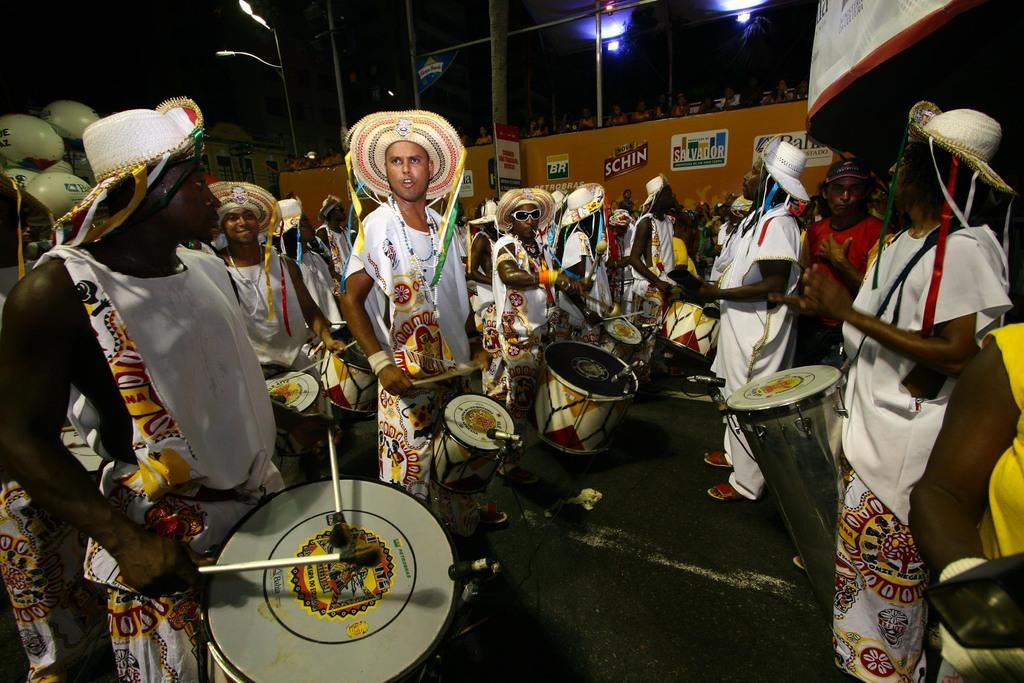What is happening in the image involving a group of people? The people in the image are playing drums with sticks. What are the people wearing on their heads? The people are wearing caps with ribbons. What can be seen in the background of the image? There is a wall and a light in the background of the image. How many boys are playing the drums in the image? The provided facts do not mention the gender of the people in the image, so it is impossible to determine the number of boys playing the drums. 